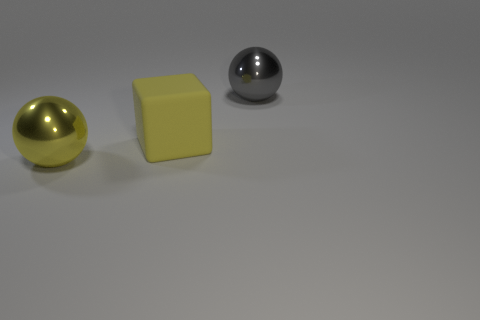Add 2 large yellow cubes. How many objects exist? 5 Subtract all balls. How many objects are left? 1 Subtract 1 yellow spheres. How many objects are left? 2 Subtract all metal spheres. Subtract all big gray metal balls. How many objects are left? 0 Add 2 gray metallic balls. How many gray metallic balls are left? 3 Add 3 big cubes. How many big cubes exist? 4 